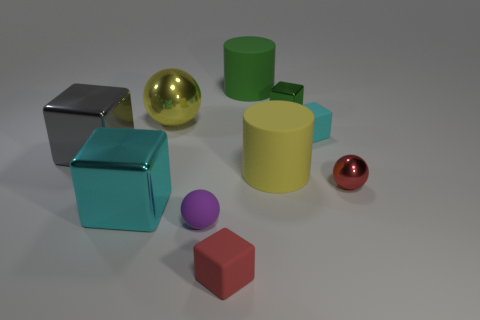Subtract all small spheres. How many spheres are left? 1 Subtract all red balls. How many balls are left? 2 Subtract 3 spheres. How many spheres are left? 0 Add 8 tiny red balls. How many tiny red balls are left? 9 Add 2 small red shiny balls. How many small red shiny balls exist? 3 Subtract 0 purple cylinders. How many objects are left? 10 Subtract all balls. How many objects are left? 7 Subtract all red balls. Subtract all purple cubes. How many balls are left? 2 Subtract all yellow cylinders. How many red blocks are left? 1 Subtract all rubber objects. Subtract all purple metal cylinders. How many objects are left? 5 